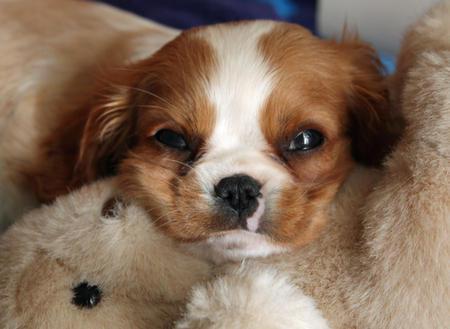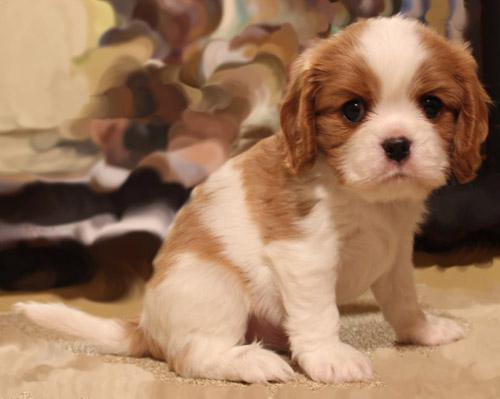The first image is the image on the left, the second image is the image on the right. For the images displayed, is the sentence "There are three dogs" factually correct? Answer yes or no. No. 